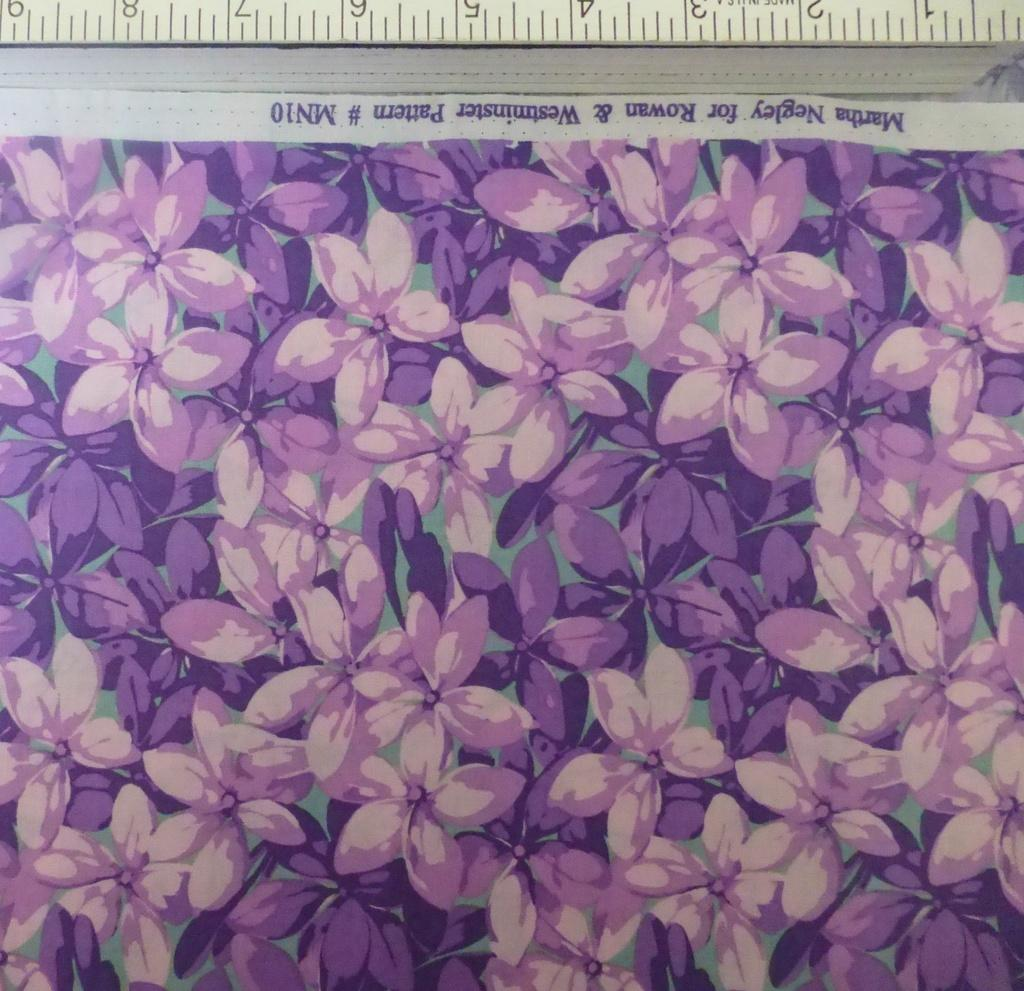<image>
Summarize the visual content of the image. Drawing of purple flowers with the number MN10 on it. 